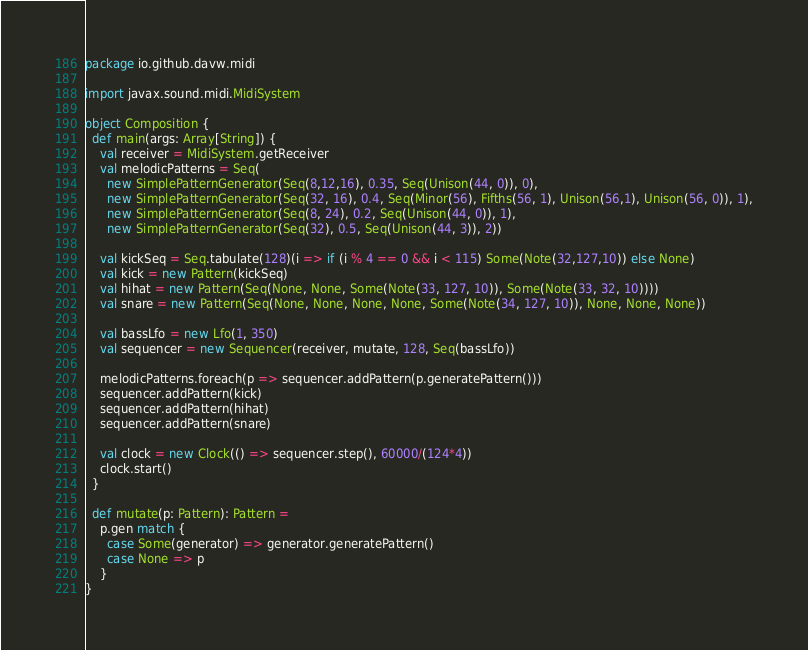<code> <loc_0><loc_0><loc_500><loc_500><_Scala_>package io.github.davw.midi

import javax.sound.midi.MidiSystem

object Composition {
  def main(args: Array[String]) {
    val receiver = MidiSystem.getReceiver
    val melodicPatterns = Seq(
      new SimplePatternGenerator(Seq(8,12,16), 0.35, Seq(Unison(44, 0)), 0),
      new SimplePatternGenerator(Seq(32, 16), 0.4, Seq(Minor(56), Fifths(56, 1), Unison(56,1), Unison(56, 0)), 1),
      new SimplePatternGenerator(Seq(8, 24), 0.2, Seq(Unison(44, 0)), 1),
      new SimplePatternGenerator(Seq(32), 0.5, Seq(Unison(44, 3)), 2))

    val kickSeq = Seq.tabulate(128)(i => if (i % 4 == 0 && i < 115) Some(Note(32,127,10)) else None)
    val kick = new Pattern(kickSeq)
    val hihat = new Pattern(Seq(None, None, Some(Note(33, 127, 10)), Some(Note(33, 32, 10))))
    val snare = new Pattern(Seq(None, None, None, None, Some(Note(34, 127, 10)), None, None, None))

    val bassLfo = new Lfo(1, 350)
    val sequencer = new Sequencer(receiver, mutate, 128, Seq(bassLfo))

    melodicPatterns.foreach(p => sequencer.addPattern(p.generatePattern()))
    sequencer.addPattern(kick)
    sequencer.addPattern(hihat)
    sequencer.addPattern(snare)

    val clock = new Clock(() => sequencer.step(), 60000/(124*4))
    clock.start()
  }

  def mutate(p: Pattern): Pattern =
    p.gen match {
      case Some(generator) => generator.generatePattern()
      case None => p
    }
}
</code> 